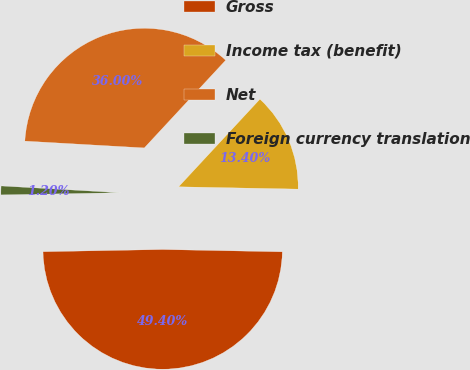Convert chart. <chart><loc_0><loc_0><loc_500><loc_500><pie_chart><fcel>Gross<fcel>Income tax (benefit)<fcel>Net<fcel>Foreign currency translation<nl><fcel>49.4%<fcel>13.4%<fcel>36.0%<fcel>1.2%<nl></chart> 